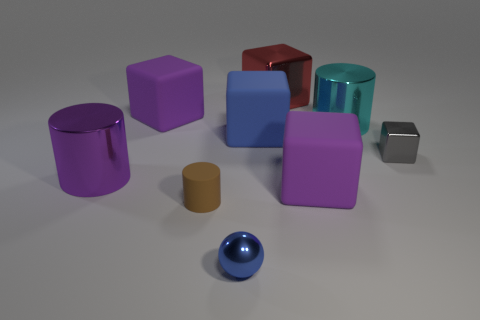Which object stands out the most due to its size and why might that be? The red cube stands out the most because of its larger size compared to the other objects in the image. Its size could be indicative of its importance or simply an artistic choice to create a focal point. 